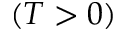Convert formula to latex. <formula><loc_0><loc_0><loc_500><loc_500>( T > 0 )</formula> 